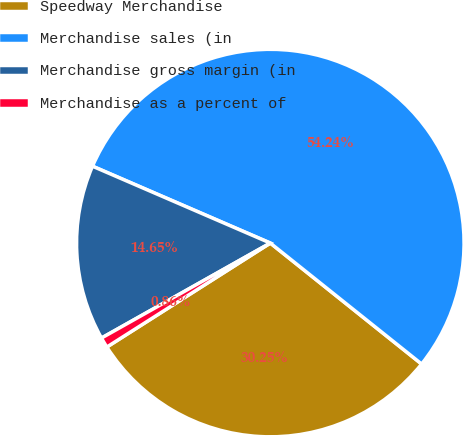Convert chart. <chart><loc_0><loc_0><loc_500><loc_500><pie_chart><fcel>Speedway Merchandise<fcel>Merchandise sales (in<fcel>Merchandise gross margin (in<fcel>Merchandise as a percent of<nl><fcel>30.25%<fcel>54.24%<fcel>14.65%<fcel>0.86%<nl></chart> 